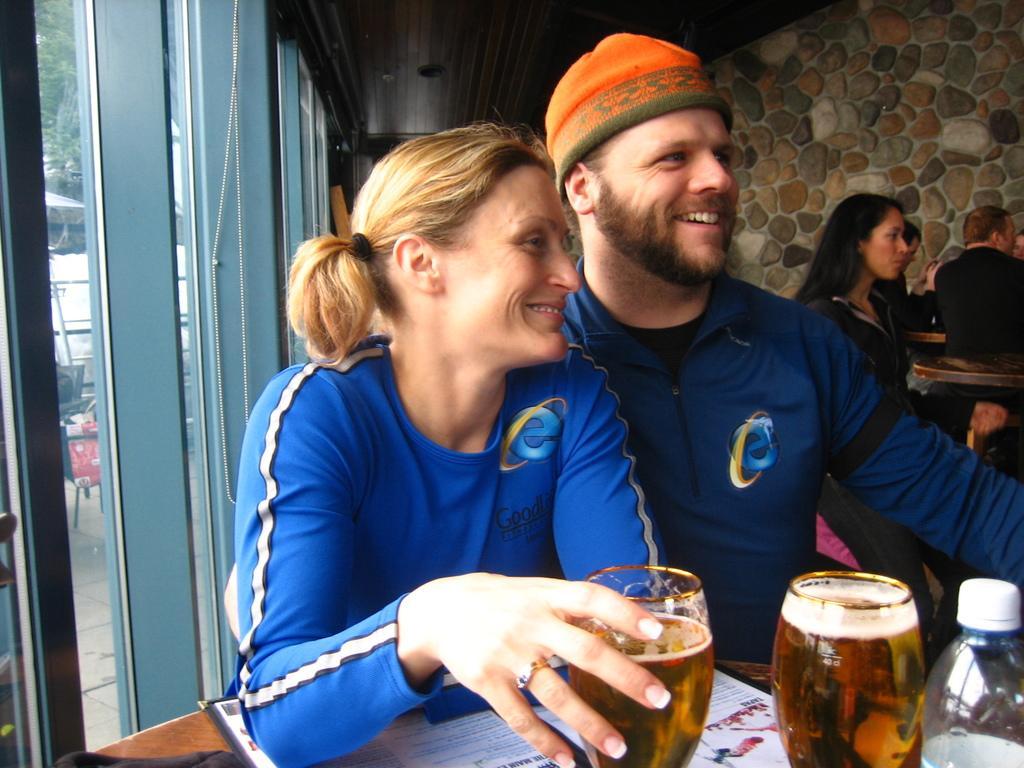In one or two sentences, can you explain what this image depicts? In this image I can see few people sitting. I can see glasses,bottle,pamphlet on the brown color table. I can see a window and trees. 